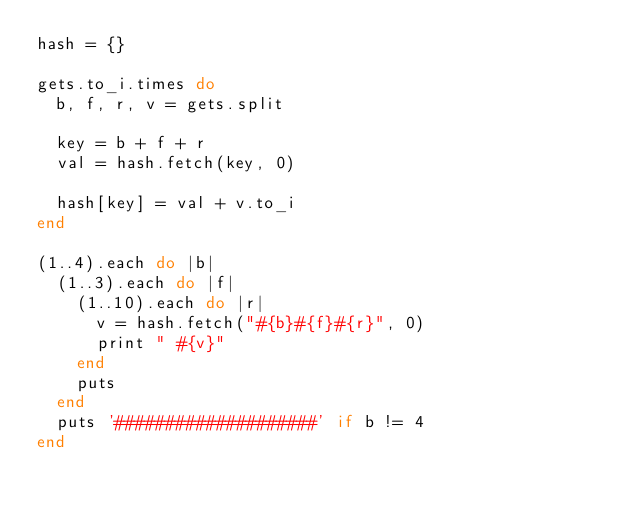Convert code to text. <code><loc_0><loc_0><loc_500><loc_500><_Ruby_>hash = {}

gets.to_i.times do
  b, f, r, v = gets.split

  key = b + f + r
  val = hash.fetch(key, 0)

  hash[key] = val + v.to_i
end

(1..4).each do |b|
  (1..3).each do |f|
    (1..10).each do |r|
      v = hash.fetch("#{b}#{f}#{r}", 0)
      print " #{v}"
    end
    puts
  end
  puts '####################' if b != 4
end

</code> 